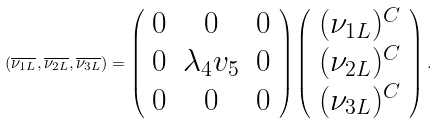<formula> <loc_0><loc_0><loc_500><loc_500>( \overline { { { \nu _ { 1 L } } } } , \overline { { { \nu _ { 2 L } } } } , \overline { { { \nu _ { 3 L } } } } ) = \left ( \begin{array} { c c c } { 0 } & { 0 } & { 0 } \\ { 0 } & { { \lambda _ { 4 } v _ { 5 } } } & { 0 } \\ { 0 } & { 0 } & { 0 } \end{array} \right ) \left ( \begin{array} { c } { { ( \nu _ { 1 L } ) ^ { C } } } \\ { { ( \nu _ { 2 L } ) ^ { C } } } \\ { { ( \nu _ { 3 L } ) ^ { C } } } \end{array} \right ) .</formula> 